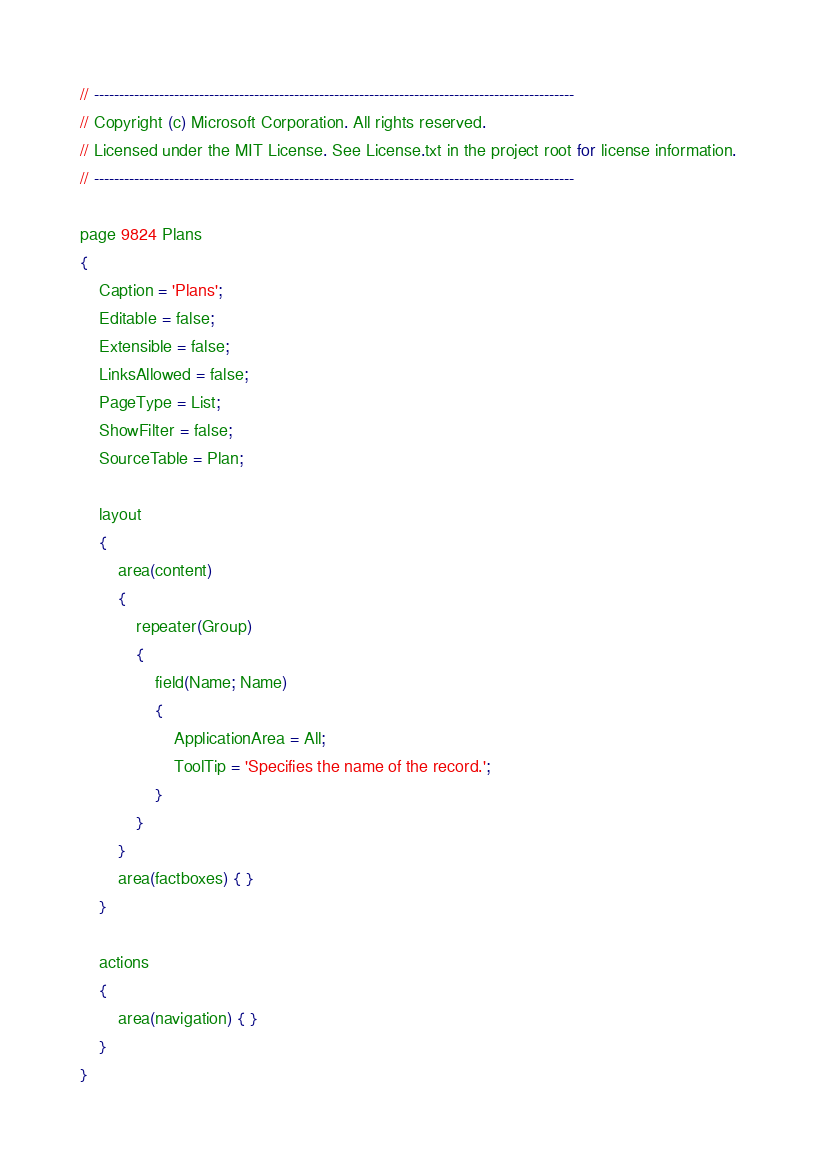Convert code to text. <code><loc_0><loc_0><loc_500><loc_500><_Perl_>// ------------------------------------------------------------------------------------------------
// Copyright (c) Microsoft Corporation. All rights reserved.
// Licensed under the MIT License. See License.txt in the project root for license information.
// ------------------------------------------------------------------------------------------------

page 9824 Plans
{
    Caption = 'Plans';
    Editable = false;
    Extensible = false;
    LinksAllowed = false;
    PageType = List;
    ShowFilter = false;
    SourceTable = Plan;

    layout
    {
        area(content)
        {
            repeater(Group)
            {
                field(Name; Name)
                {
                    ApplicationArea = All;
                    ToolTip = 'Specifies the name of the record.';
                }
            }
        }
        area(factboxes) { }
    }

    actions
    {
        area(navigation) { }
    }
}

</code> 